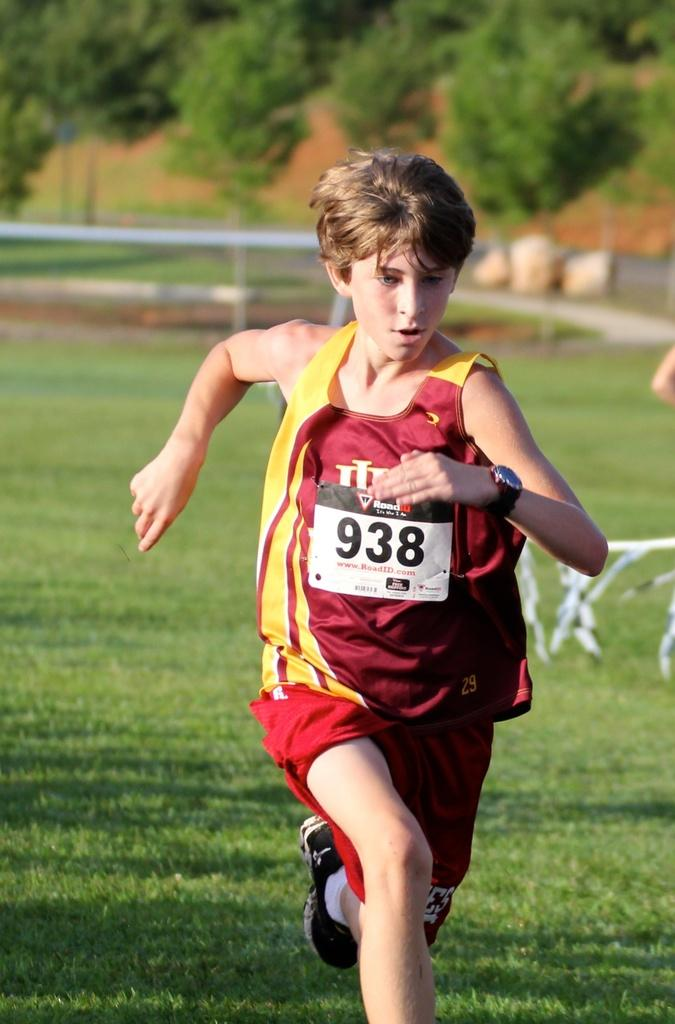Who is the main subject in the image? There is a boy in the image. What is the boy doing in the image? The boy is running in the image. Where is the boy running? The boy is running on a grassland in the image. What can be seen in the background of the image? There are trees in the background of the image. How is the background of the image depicted? The background is blurred in the image. What type of interest rate is the boy discussing with his friend in the image? There is no indication in the image that the boy is discussing interest rates or any financial matters. 